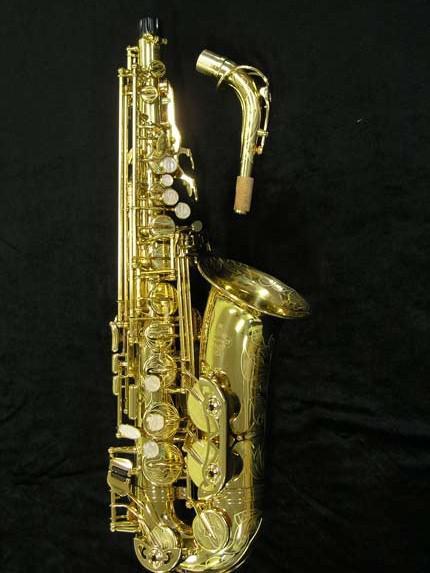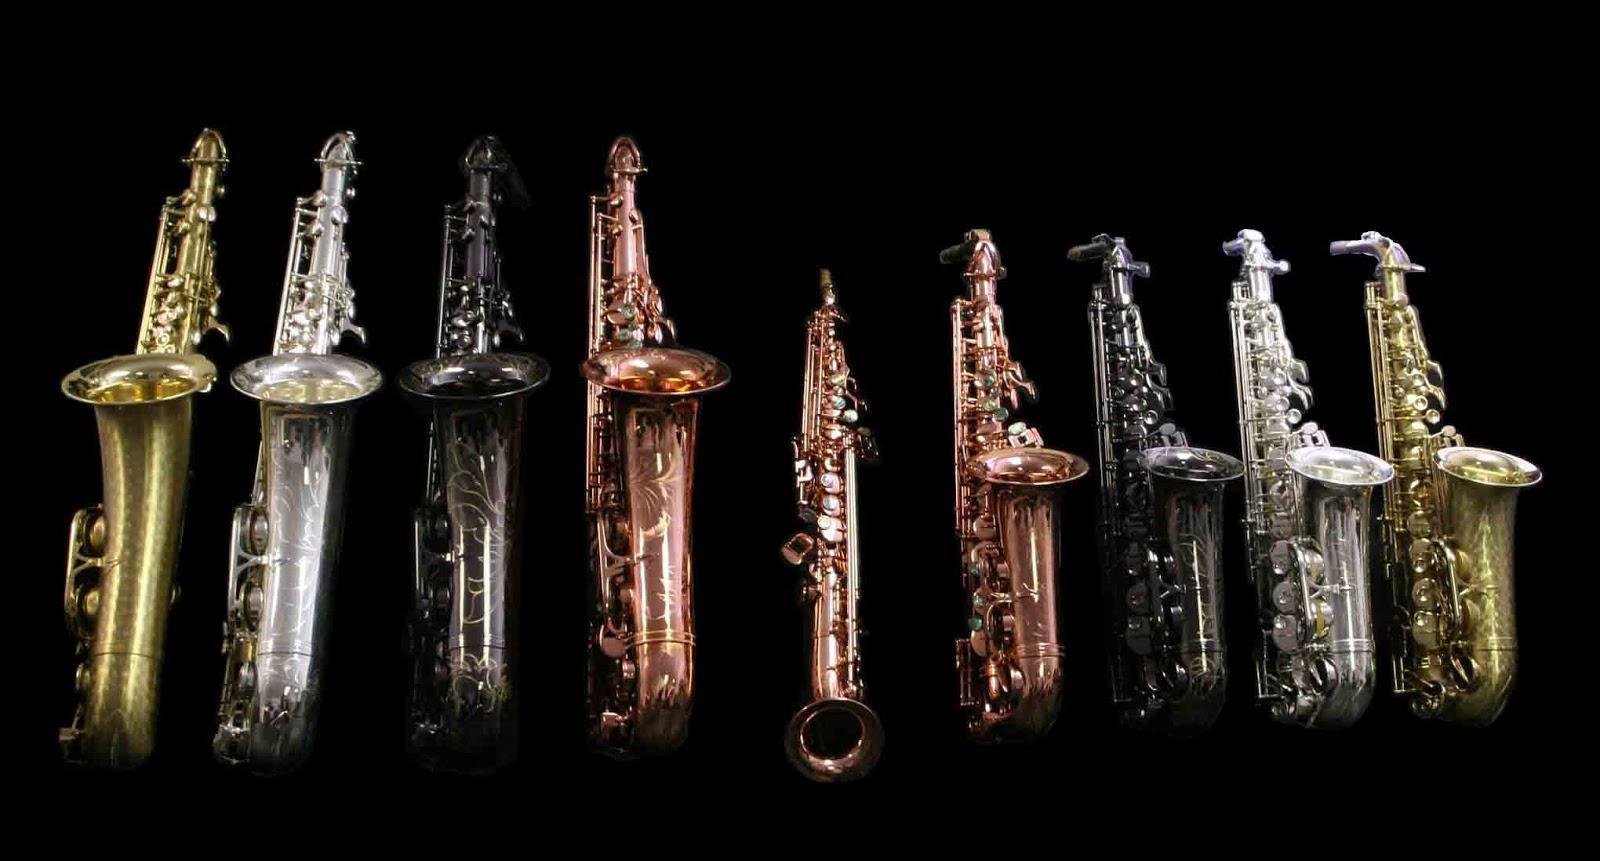The first image is the image on the left, the second image is the image on the right. Given the left and right images, does the statement "There are more instruments in the image on the right." hold true? Answer yes or no. Yes. The first image is the image on the left, the second image is the image on the right. Analyze the images presented: Is the assertion "An image shows one saxophone with its mouthpiece separate on the display." valid? Answer yes or no. Yes. 